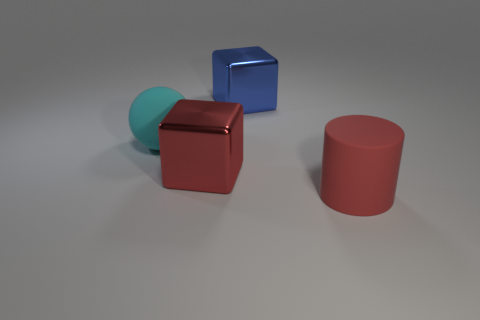Add 2 large balls. How many objects exist? 6 Subtract all cylinders. How many objects are left? 3 Subtract all red things. Subtract all tiny cyan rubber things. How many objects are left? 2 Add 1 red cylinders. How many red cylinders are left? 2 Add 1 large red cubes. How many large red cubes exist? 2 Subtract 0 gray balls. How many objects are left? 4 